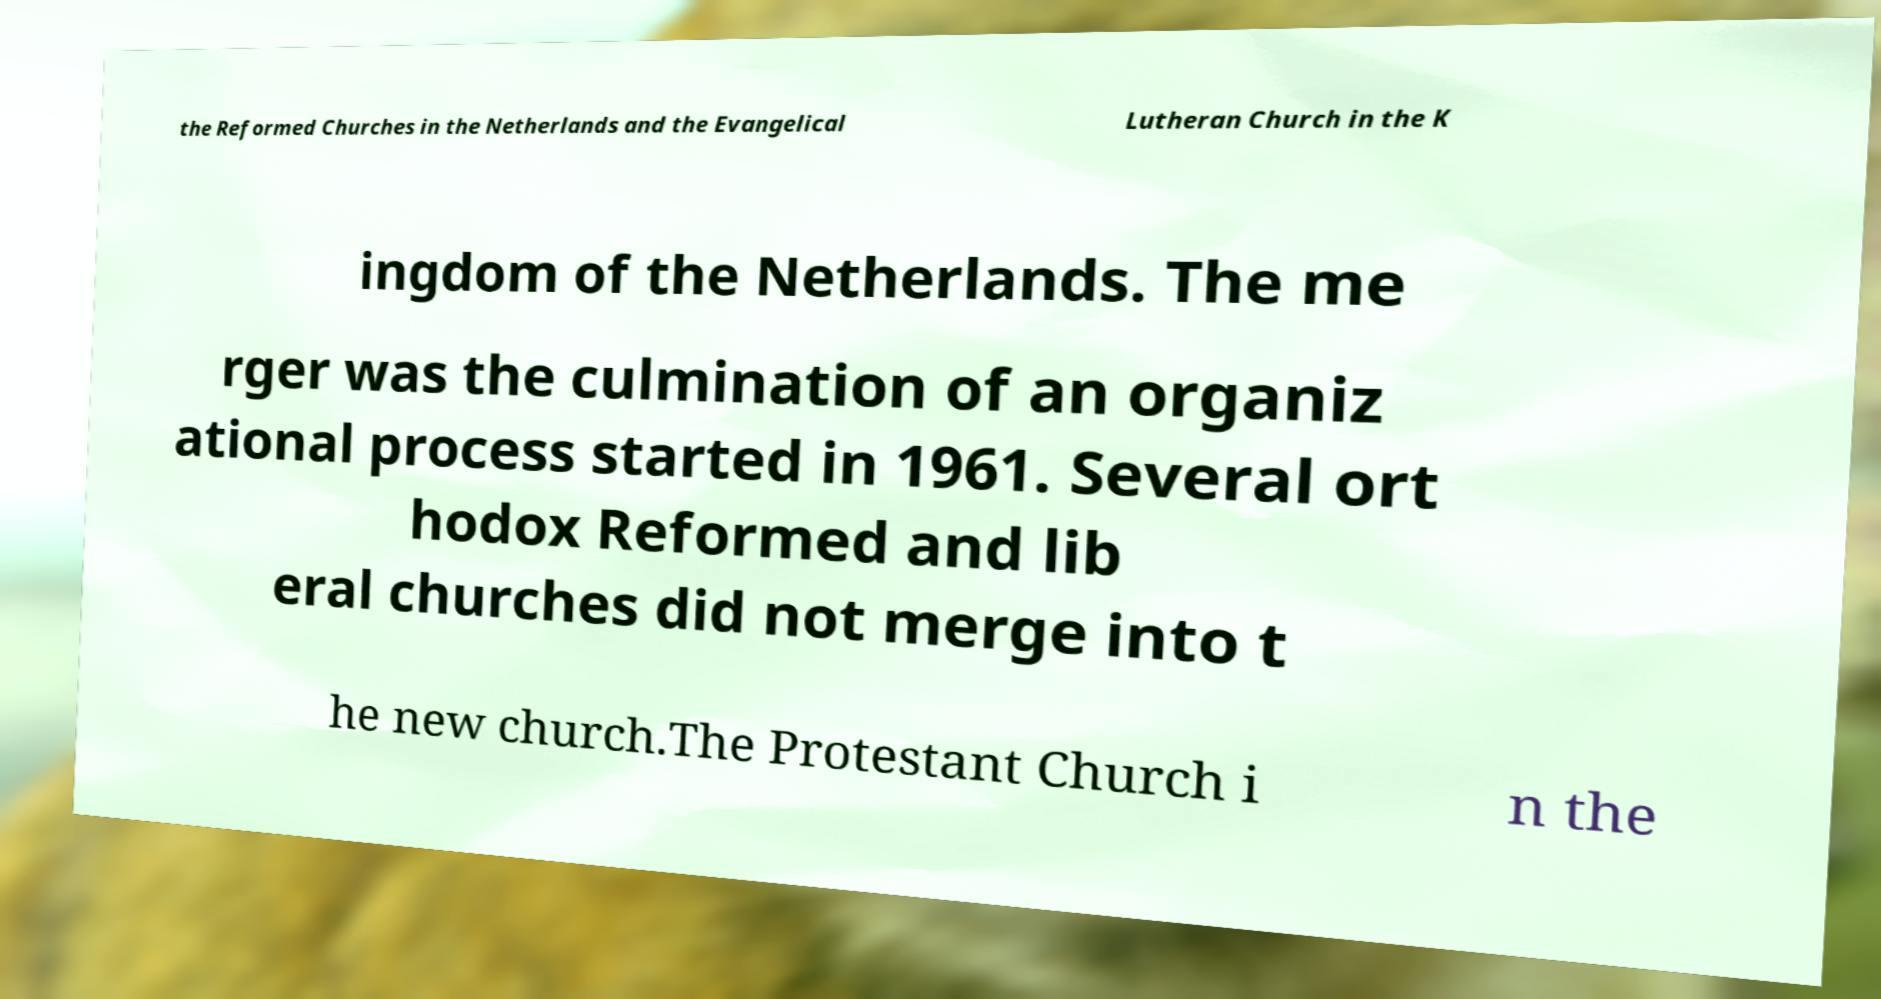I need the written content from this picture converted into text. Can you do that? the Reformed Churches in the Netherlands and the Evangelical Lutheran Church in the K ingdom of the Netherlands. The me rger was the culmination of an organiz ational process started in 1961. Several ort hodox Reformed and lib eral churches did not merge into t he new church.The Protestant Church i n the 